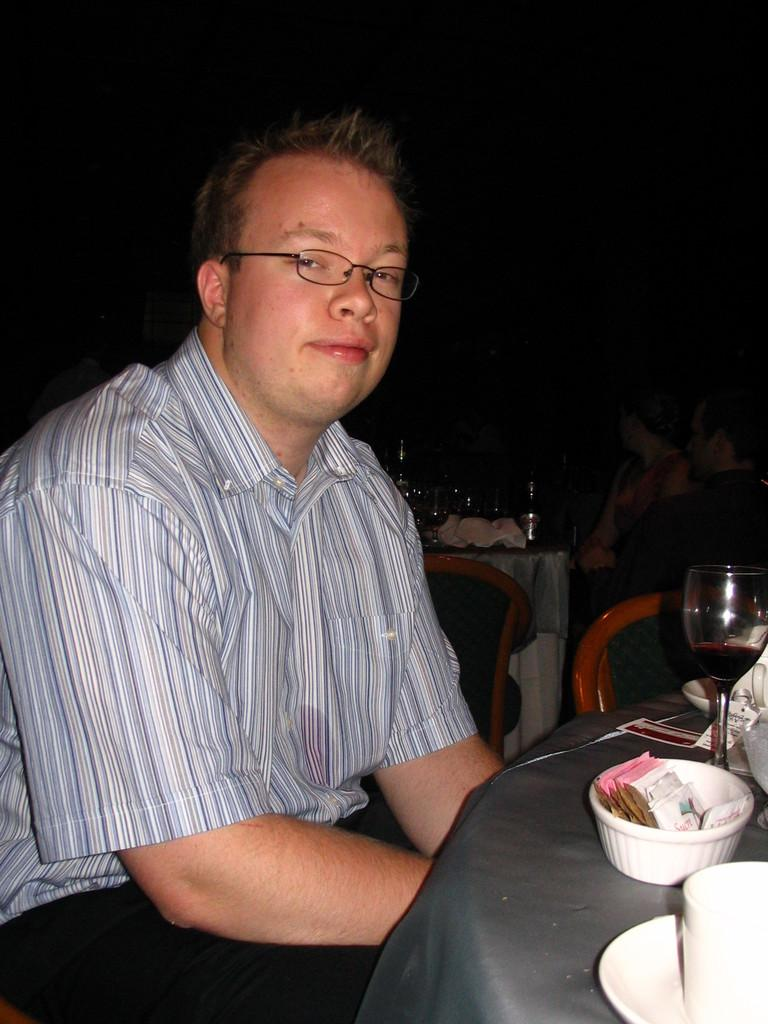What is the man doing in the image? The man is sitting on the left side of the image. What is the man wearing in the image? The man is wearing a shirt and spectacles in the image. What objects can be seen on the table in the image? There is a white glass, a bowl, and plates on a dining table in the image. How many pets are visible in the image? There are no pets visible in the image. What type of stove is used to cook the food in the image? There is no stove present in the image. 